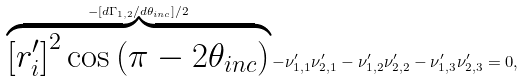Convert formula to latex. <formula><loc_0><loc_0><loc_500><loc_500>\overbrace { \left [ r ^ { \prime } _ { i } \right ] ^ { 2 } \cos \left ( \pi - 2 \theta _ { i n c } \right ) } ^ { - \left [ d \Gamma _ { 1 , 2 } / d \theta _ { i n c } \right ] / 2 } - \nu ^ { \prime } _ { 1 , 1 } \nu ^ { \prime } _ { 2 , 1 } - \nu ^ { \prime } _ { 1 , 2 } \nu ^ { \prime } _ { 2 , 2 } - \nu ^ { \prime } _ { 1 , 3 } \nu ^ { \prime } _ { 2 , 3 } & = 0 ,</formula> 